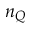Convert formula to latex. <formula><loc_0><loc_0><loc_500><loc_500>n _ { Q }</formula> 